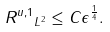<formula> <loc_0><loc_0><loc_500><loc_500>\| R ^ { u , 1 } \| _ { L ^ { 2 } } \leq C \epsilon ^ { \frac { 1 } { 4 } } .</formula> 